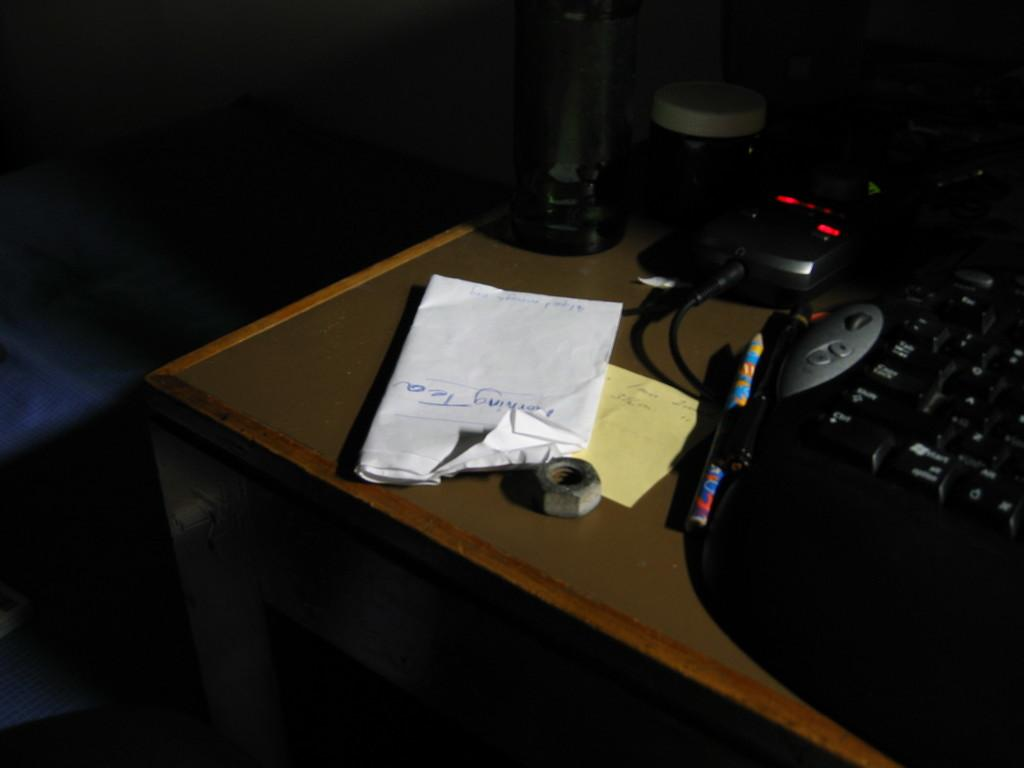<image>
Provide a brief description of the given image. The word tea is hand written upside down on the note pad beside the keyboard. 